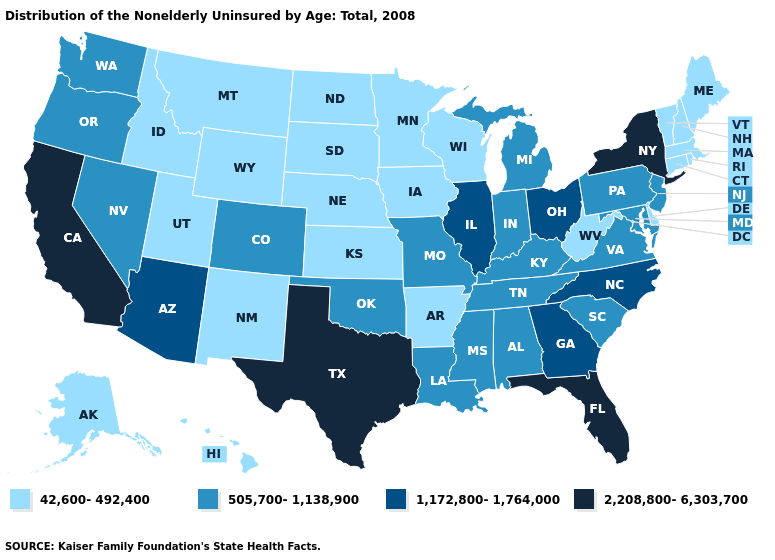Name the states that have a value in the range 42,600-492,400?
Write a very short answer. Alaska, Arkansas, Connecticut, Delaware, Hawaii, Idaho, Iowa, Kansas, Maine, Massachusetts, Minnesota, Montana, Nebraska, New Hampshire, New Mexico, North Dakota, Rhode Island, South Dakota, Utah, Vermont, West Virginia, Wisconsin, Wyoming. Which states have the highest value in the USA?
Write a very short answer. California, Florida, New York, Texas. What is the value of Idaho?
Give a very brief answer. 42,600-492,400. Name the states that have a value in the range 505,700-1,138,900?
Be succinct. Alabama, Colorado, Indiana, Kentucky, Louisiana, Maryland, Michigan, Mississippi, Missouri, Nevada, New Jersey, Oklahoma, Oregon, Pennsylvania, South Carolina, Tennessee, Virginia, Washington. What is the value of Colorado?
Quick response, please. 505,700-1,138,900. Name the states that have a value in the range 2,208,800-6,303,700?
Concise answer only. California, Florida, New York, Texas. What is the value of Nebraska?
Give a very brief answer. 42,600-492,400. Name the states that have a value in the range 505,700-1,138,900?
Be succinct. Alabama, Colorado, Indiana, Kentucky, Louisiana, Maryland, Michigan, Mississippi, Missouri, Nevada, New Jersey, Oklahoma, Oregon, Pennsylvania, South Carolina, Tennessee, Virginia, Washington. Among the states that border Oregon , which have the highest value?
Short answer required. California. Among the states that border Michigan , does Ohio have the lowest value?
Short answer required. No. What is the value of Vermont?
Concise answer only. 42,600-492,400. Is the legend a continuous bar?
Concise answer only. No. What is the lowest value in states that border Texas?
Be succinct. 42,600-492,400. Name the states that have a value in the range 42,600-492,400?
Answer briefly. Alaska, Arkansas, Connecticut, Delaware, Hawaii, Idaho, Iowa, Kansas, Maine, Massachusetts, Minnesota, Montana, Nebraska, New Hampshire, New Mexico, North Dakota, Rhode Island, South Dakota, Utah, Vermont, West Virginia, Wisconsin, Wyoming. Name the states that have a value in the range 42,600-492,400?
Concise answer only. Alaska, Arkansas, Connecticut, Delaware, Hawaii, Idaho, Iowa, Kansas, Maine, Massachusetts, Minnesota, Montana, Nebraska, New Hampshire, New Mexico, North Dakota, Rhode Island, South Dakota, Utah, Vermont, West Virginia, Wisconsin, Wyoming. 